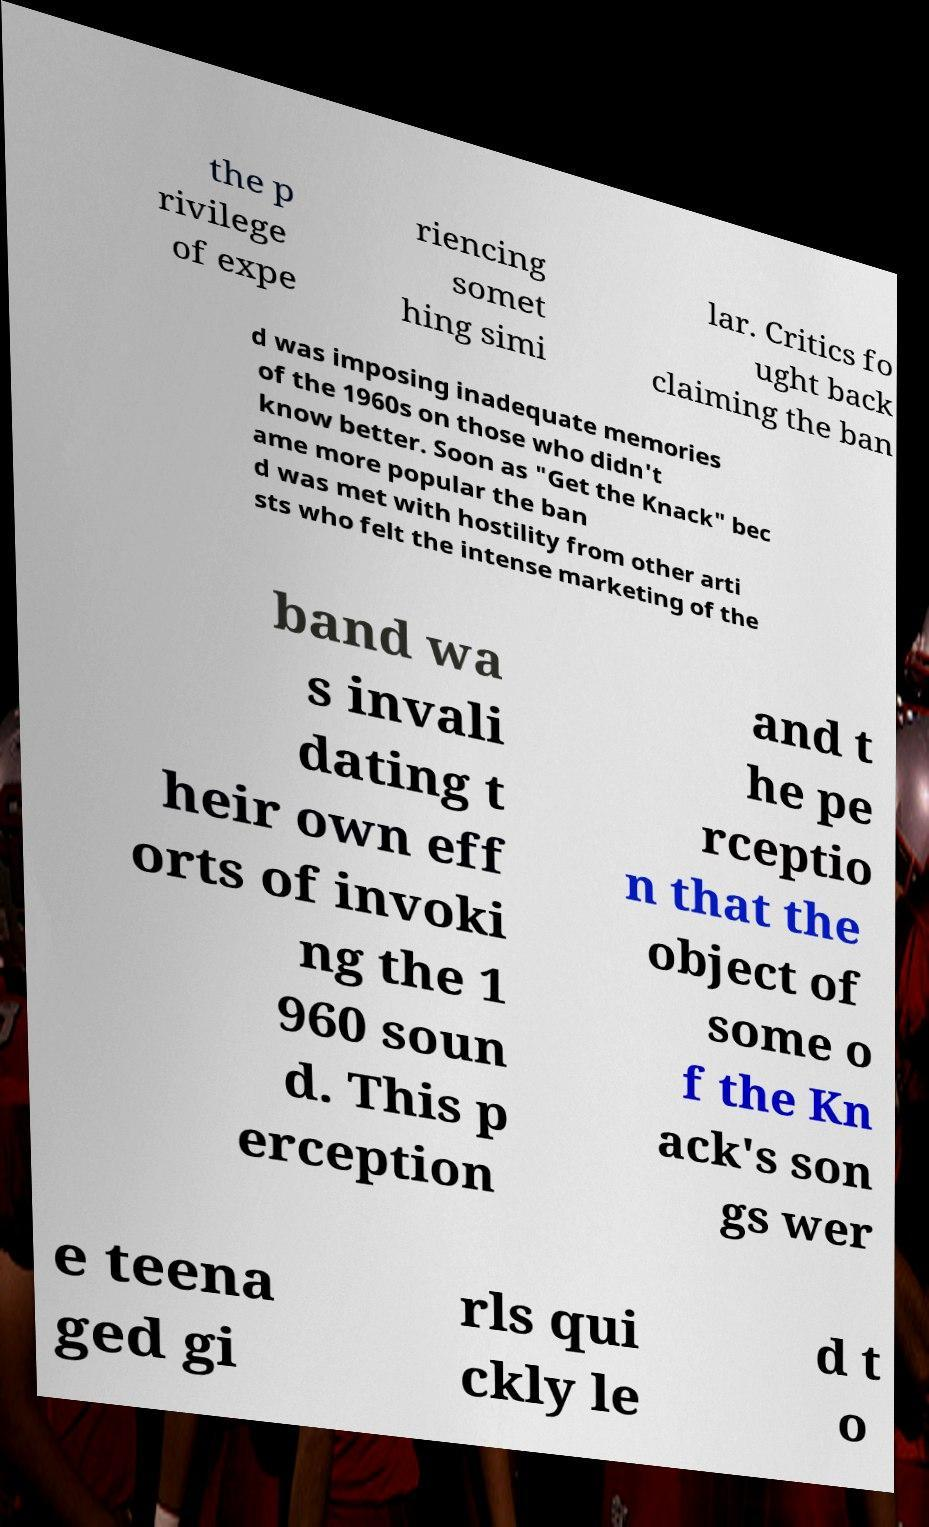Could you assist in decoding the text presented in this image and type it out clearly? the p rivilege of expe riencing somet hing simi lar. Critics fo ught back claiming the ban d was imposing inadequate memories of the 1960s on those who didn't know better. Soon as "Get the Knack" bec ame more popular the ban d was met with hostility from other arti sts who felt the intense marketing of the band wa s invali dating t heir own eff orts of invoki ng the 1 960 soun d. This p erception and t he pe rceptio n that the object of some o f the Kn ack's son gs wer e teena ged gi rls qui ckly le d t o 